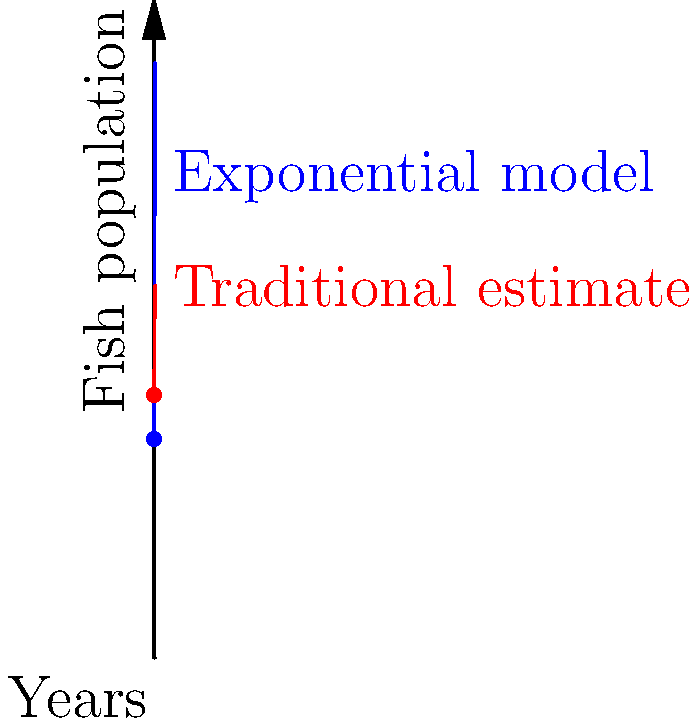As an Inuit musician deeply connected to your cultural roots, you're interested in sustainable fishing practices. Your community has been tracking the Arctic char population in a nearby lake. The initial population was estimated at 1000 fish. Using traditional methods, elders predict a linear growth of about 100 fish per year. However, a biologist suggests an exponential growth model with a rate of 20% per year. After 5 years, what is the difference between the exponential model's prediction and the traditional linear estimate? Let's approach this step-by-step:

1) For the traditional linear estimate:
   - Initial population: 1200 (slightly higher than the exponential model's start)
   - Growth rate: 100 fish per year
   - After 5 years: $1200 + (100 * 5) = 1700$ fish

2) For the exponential growth model:
   - Initial population: 1000 fish
   - Growth rate: 20% per year
   - Formula: $P(t) = P_0 * e^{rt}$
     where $P_0$ is initial population, $r$ is growth rate, and $t$ is time in years

3) Calculating the exponential model after 5 years:
   $P(5) = 1000 * e^{0.2 * 5}$
   $= 1000 * e^1$
   $= 1000 * 2.71828$
   $\approx 2718$ fish

4) Finding the difference:
   Exponential model prediction: 2718 fish
   Traditional linear estimate: 1700 fish
   Difference: $2718 - 1700 = 1018$ fish

The exponential model predicts 1018 more fish than the traditional linear estimate after 5 years.
Answer: 1018 fish 